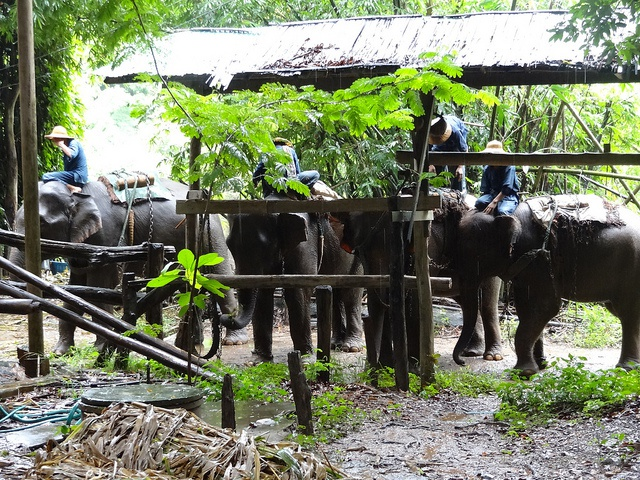Describe the objects in this image and their specific colors. I can see elephant in black, white, gray, and darkgray tones, elephant in black, gray, and darkgray tones, elephant in black, gray, white, and darkgray tones, elephant in black, gray, darkgreen, and darkgray tones, and people in black, white, navy, and gray tones in this image. 